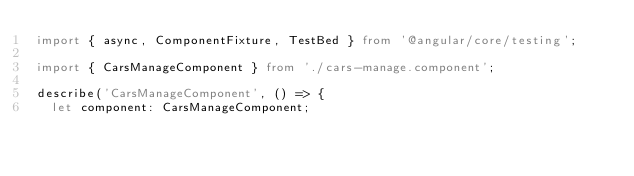Convert code to text. <code><loc_0><loc_0><loc_500><loc_500><_TypeScript_>import { async, ComponentFixture, TestBed } from '@angular/core/testing';

import { CarsManageComponent } from './cars-manage.component';

describe('CarsManageComponent', () => {
  let component: CarsManageComponent;</code> 